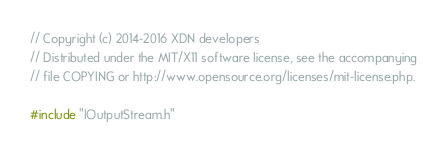Convert code to text. <code><loc_0><loc_0><loc_500><loc_500><_C++_>
// Copyright (c) 2014-2016 XDN developers
// Distributed under the MIT/X11 software license, see the accompanying
// file COPYING or http://www.opensource.org/licenses/mit-license.php.

#include "IOutputStream.h"
</code> 